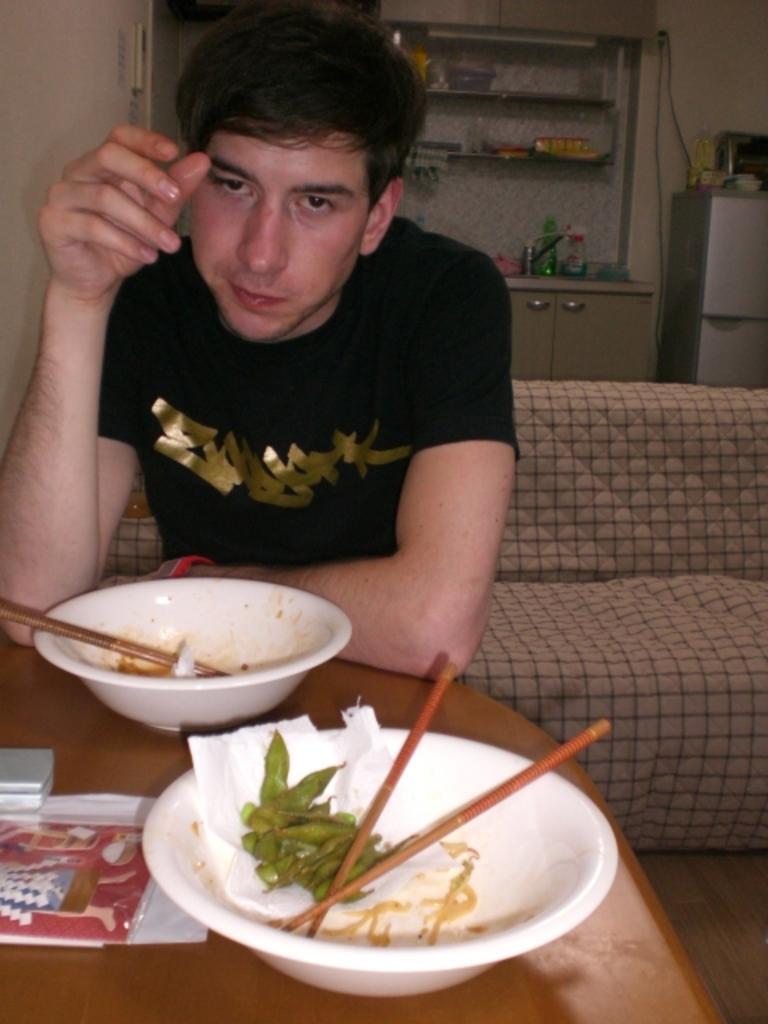Please provide a concise description of this image. As we can see in the image there is man sitting on sofa and in the front there is a table. On table there are bowls, chopstick and a paper. 